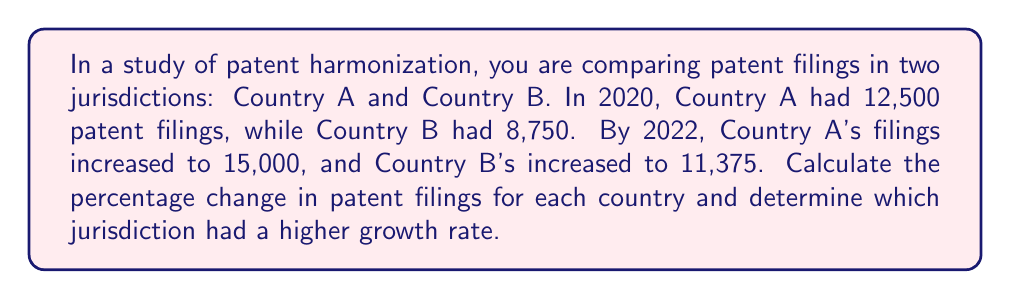Could you help me with this problem? To solve this problem, we'll calculate the percentage change for each country separately and then compare them.

For Country A:
1. Initial value (2020): $12,500$
2. Final value (2022): $15,000$
3. Absolute change: $15,000 - 12,500 = 2,500$
4. Percentage change formula: $\frac{\text{Change}}{\text{Initial Value}} \times 100\%$
5. Percentage change: $\frac{2,500}{12,500} \times 100\% = 0.2 \times 100\% = 20\%$

For Country B:
1. Initial value (2020): $8,750$
2. Final value (2022): $11,375$
3. Absolute change: $11,375 - 8,750 = 2,625$
4. Percentage change: $\frac{2,625}{8,750} \times 100\% = 0.3 \times 100\% = 30\%$

Comparing the two:
Country A's growth rate: 20%
Country B's growth rate: 30%

Therefore, Country B had a higher growth rate in patent filings.
Answer: Country A: 20% increase; Country B: 30% increase. Country B had higher growth. 